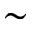<formula> <loc_0><loc_0><loc_500><loc_500>\sim</formula> 